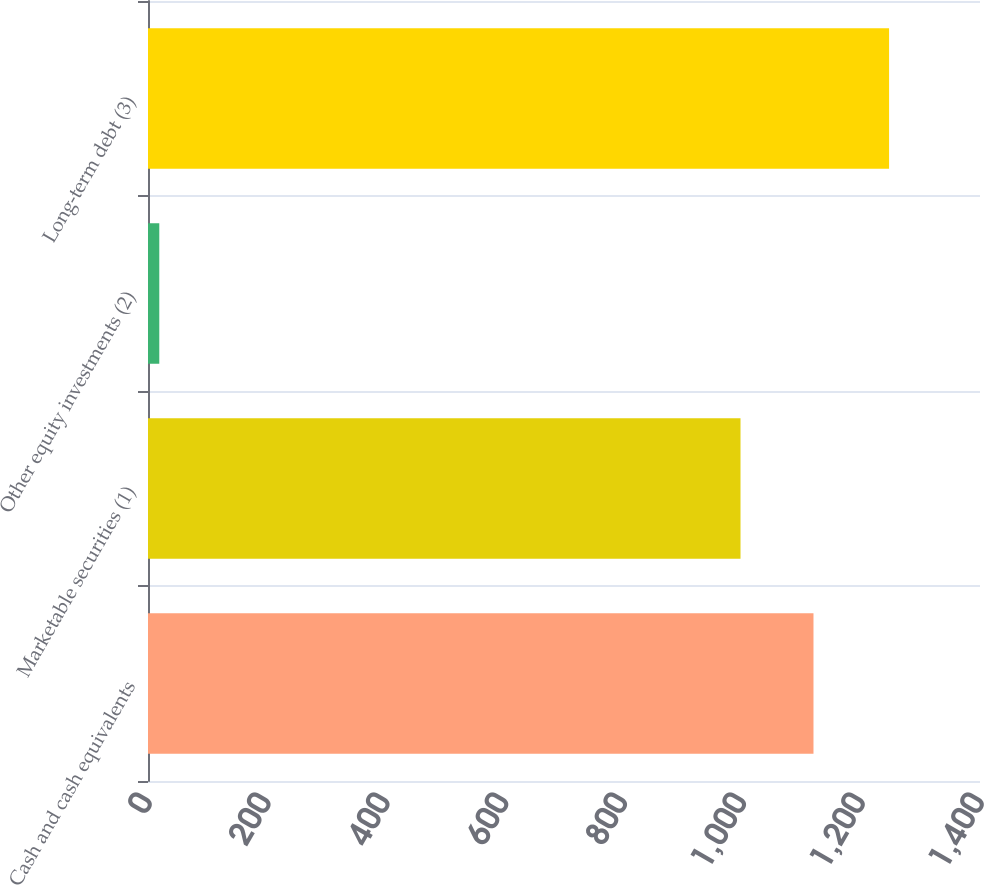Convert chart to OTSL. <chart><loc_0><loc_0><loc_500><loc_500><bar_chart><fcel>Cash and cash equivalents<fcel>Marketable securities (1)<fcel>Other equity investments (2)<fcel>Long-term debt (3)<nl><fcel>1119.8<fcel>997<fcel>19<fcel>1247<nl></chart> 